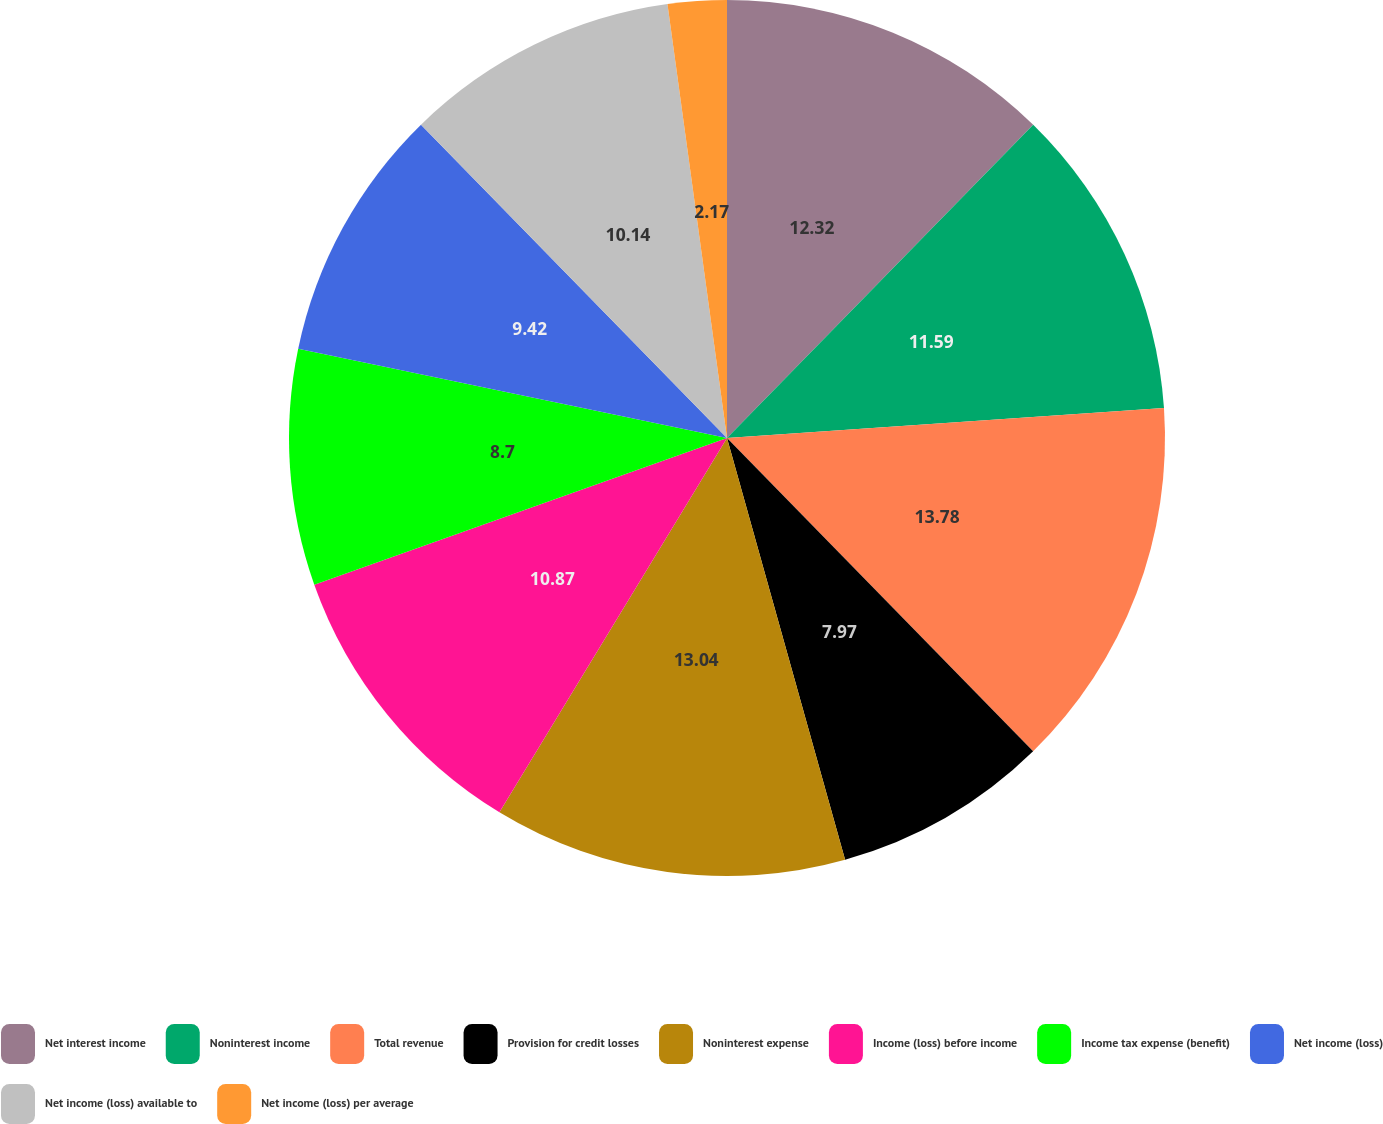<chart> <loc_0><loc_0><loc_500><loc_500><pie_chart><fcel>Net interest income<fcel>Noninterest income<fcel>Total revenue<fcel>Provision for credit losses<fcel>Noninterest expense<fcel>Income (loss) before income<fcel>Income tax expense (benefit)<fcel>Net income (loss)<fcel>Net income (loss) available to<fcel>Net income (loss) per average<nl><fcel>12.32%<fcel>11.59%<fcel>13.77%<fcel>7.97%<fcel>13.04%<fcel>10.87%<fcel>8.7%<fcel>9.42%<fcel>10.14%<fcel>2.17%<nl></chart> 